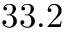<formula> <loc_0><loc_0><loc_500><loc_500>3 3 . 2</formula> 